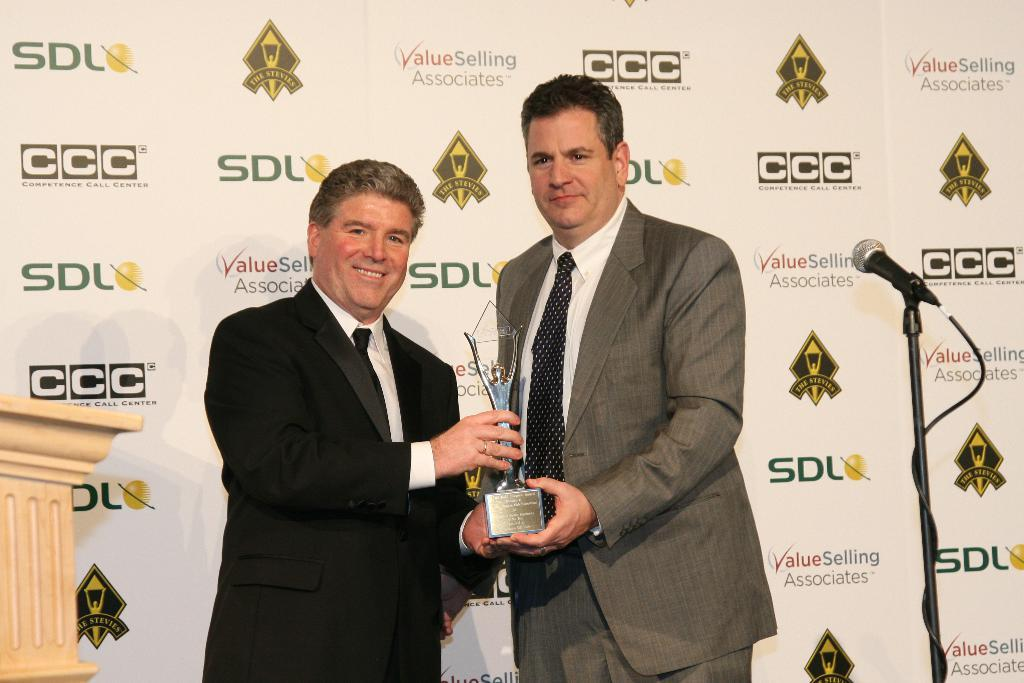How many people are in the image? There are two people standing in the middle of the image. What are the people holding? The people are holding a memorandum. What can be seen on the right side of the image? There is a mac, a table, and a stand on the right side of the image. What is visible in the background of the image? There is a banner in the background of the image. What grade does the bear receive on its report card in the image? There is no bear present in the image, and therefore no report card or grade can be observed. 